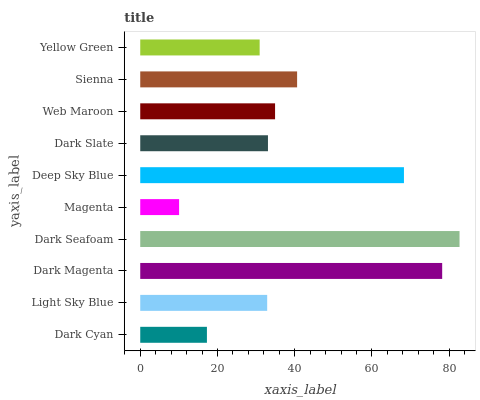Is Magenta the minimum?
Answer yes or no. Yes. Is Dark Seafoam the maximum?
Answer yes or no. Yes. Is Light Sky Blue the minimum?
Answer yes or no. No. Is Light Sky Blue the maximum?
Answer yes or no. No. Is Light Sky Blue greater than Dark Cyan?
Answer yes or no. Yes. Is Dark Cyan less than Light Sky Blue?
Answer yes or no. Yes. Is Dark Cyan greater than Light Sky Blue?
Answer yes or no. No. Is Light Sky Blue less than Dark Cyan?
Answer yes or no. No. Is Web Maroon the high median?
Answer yes or no. Yes. Is Dark Slate the low median?
Answer yes or no. Yes. Is Magenta the high median?
Answer yes or no. No. Is Magenta the low median?
Answer yes or no. No. 